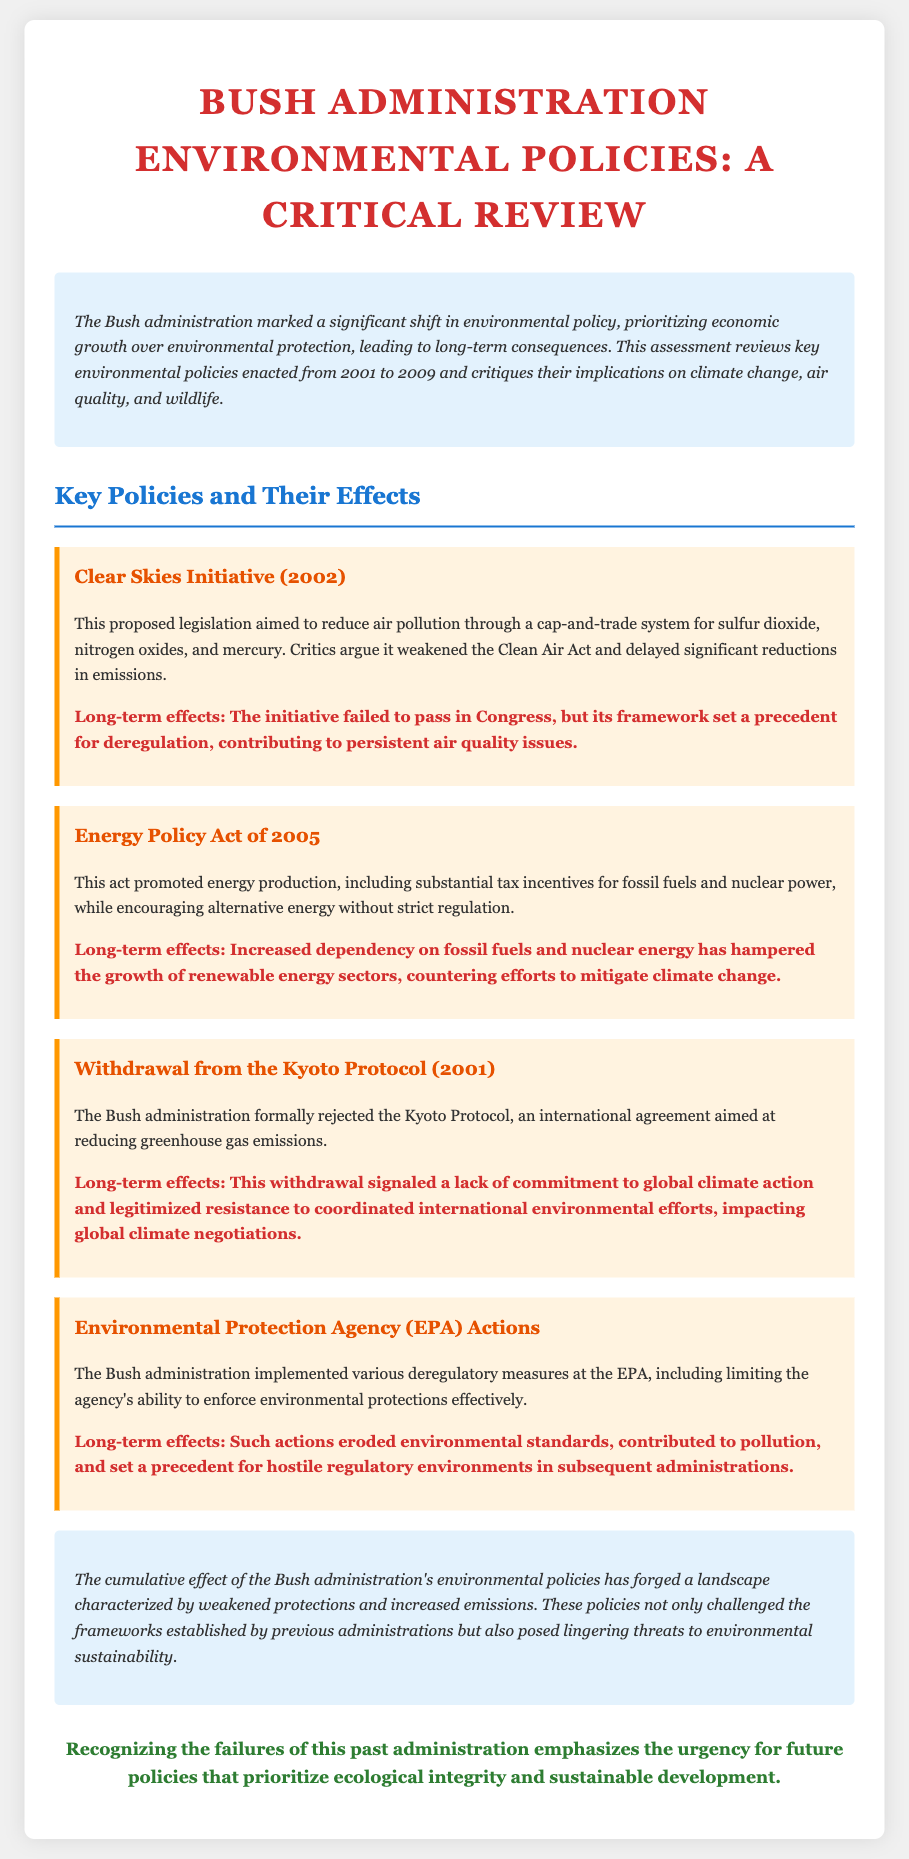What is the title of the document? The title is the main heading located at the top of the document, summarizing its content.
Answer: Bush Administration Environmental Policies: A Critical Review What year did the Bush administration withdraw from the Kyoto Protocol? The withdrawal year is specified in the section about the Kyoto Protocol.
Answer: 2001 What does the Clear Skies Initiative aim to reduce? This initiative specifically targets pollution types mentioned in the policy section.
Answer: Air pollution Which act promoted tax incentives for fossil fuels? The act promoting these incentives is highlighted in the relevant section discussing energy policy.
Answer: Energy Policy Act of 2005 What long-term effect did the Energy Policy Act have? This effect is mentioned in the policy's impact statement and connects to the broader consequences of the act.
Answer: Increased dependency on fossil fuels What is a significant consequence of the EPA actions under the Bush administration? This consequence is stated as a long-term effect reflecting on the broader implications of those actions.
Answer: Eroded environmental standards What was a primary focus of the Bush administration's environmental policies? This focus is indicated in the introductory section describing the administration's overarching approach.
Answer: Economic growth What type of document is this? The document type is specified in various contexts, particularly in its introduction and content organization.
Answer: Note 